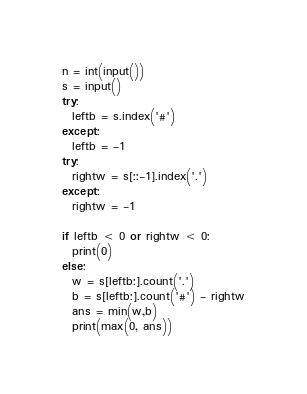Convert code to text. <code><loc_0><loc_0><loc_500><loc_500><_Python_>n = int(input())
s = input()
try:
  leftb = s.index('#')
except:
  leftb = -1
try:
  rightw = s[::-1].index('.')
except:
  rightw = -1

if leftb < 0 or rightw < 0:
  print(0)
else:
  w = s[leftb:].count('.')
  b = s[leftb:].count('#') - rightw
  ans = min(w,b)
  print(max(0, ans))</code> 